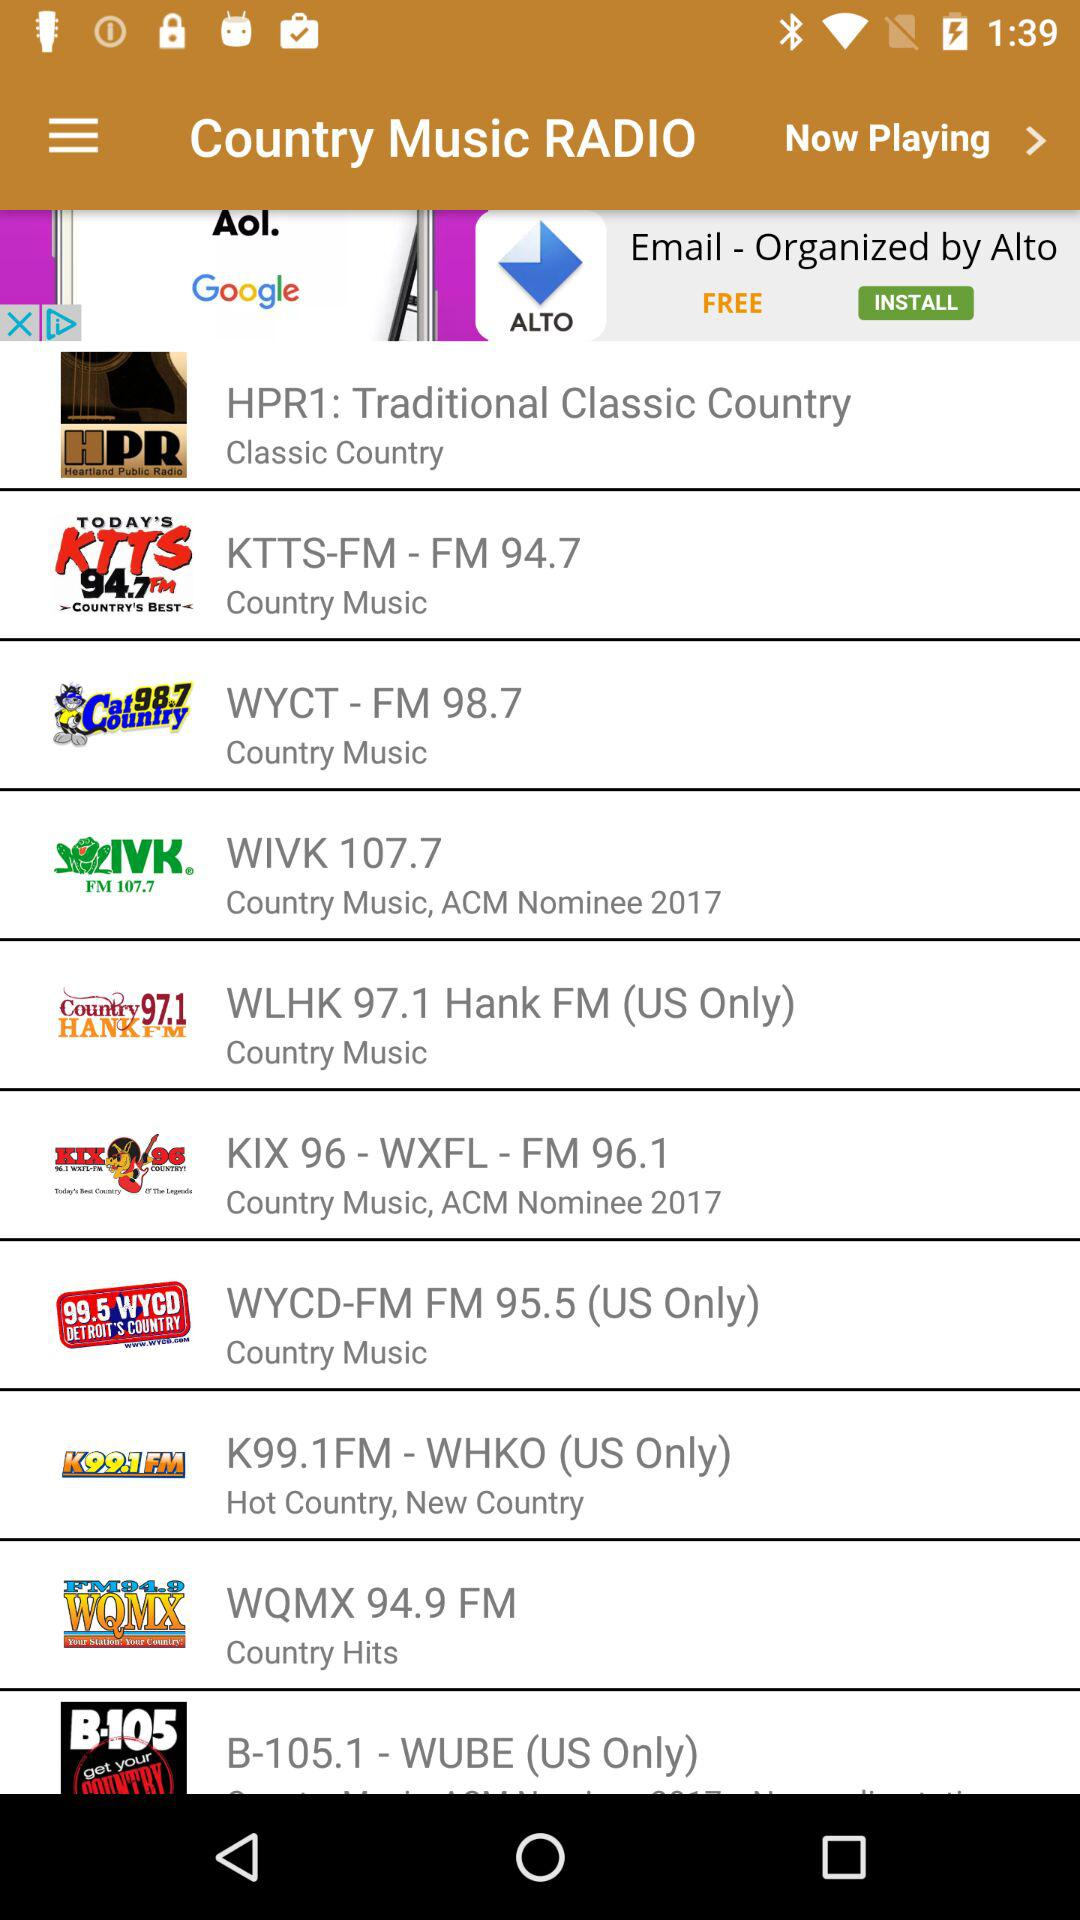What is the frequency of KTTS-FM? The frequency is 94.7. 